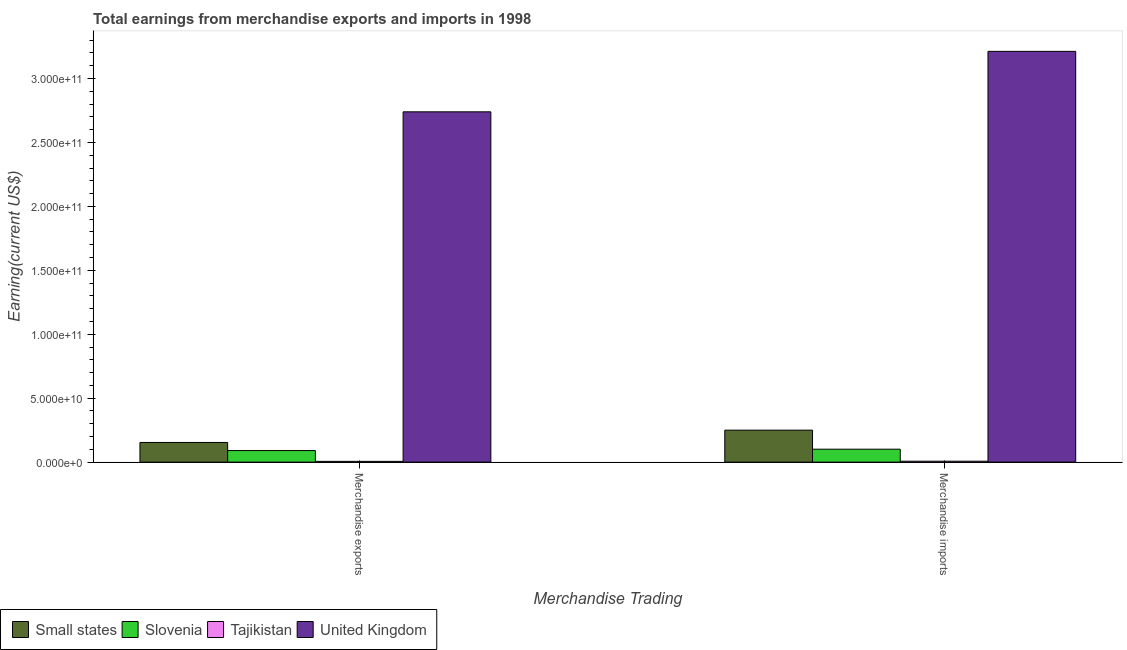How many different coloured bars are there?
Keep it short and to the point. 4. How many groups of bars are there?
Your answer should be very brief. 2. Are the number of bars per tick equal to the number of legend labels?
Keep it short and to the point. Yes. Are the number of bars on each tick of the X-axis equal?
Your answer should be compact. Yes. What is the label of the 2nd group of bars from the left?
Your answer should be compact. Merchandise imports. What is the earnings from merchandise imports in United Kingdom?
Make the answer very short. 3.21e+11. Across all countries, what is the maximum earnings from merchandise exports?
Offer a very short reply. 2.74e+11. Across all countries, what is the minimum earnings from merchandise exports?
Provide a short and direct response. 5.95e+08. In which country was the earnings from merchandise exports maximum?
Keep it short and to the point. United Kingdom. In which country was the earnings from merchandise imports minimum?
Your answer should be very brief. Tajikistan. What is the total earnings from merchandise exports in the graph?
Make the answer very short. 2.99e+11. What is the difference between the earnings from merchandise exports in Slovenia and that in Small states?
Provide a short and direct response. -6.33e+09. What is the difference between the earnings from merchandise exports in Small states and the earnings from merchandise imports in United Kingdom?
Your answer should be compact. -3.06e+11. What is the average earnings from merchandise imports per country?
Make the answer very short. 8.93e+1. What is the difference between the earnings from merchandise imports and earnings from merchandise exports in Slovenia?
Ensure brevity in your answer.  1.06e+09. In how many countries, is the earnings from merchandise imports greater than 220000000000 US$?
Your response must be concise. 1. What is the ratio of the earnings from merchandise imports in Tajikistan to that in United Kingdom?
Your answer should be very brief. 0. What does the 2nd bar from the left in Merchandise exports represents?
Make the answer very short. Slovenia. What does the 4th bar from the right in Merchandise exports represents?
Ensure brevity in your answer.  Small states. How many bars are there?
Your response must be concise. 8. How many countries are there in the graph?
Provide a succinct answer. 4. Are the values on the major ticks of Y-axis written in scientific E-notation?
Keep it short and to the point. Yes. Does the graph contain grids?
Your answer should be very brief. No. How many legend labels are there?
Keep it short and to the point. 4. How are the legend labels stacked?
Provide a succinct answer. Horizontal. What is the title of the graph?
Ensure brevity in your answer.  Total earnings from merchandise exports and imports in 1998. Does "Serbia" appear as one of the legend labels in the graph?
Provide a succinct answer. No. What is the label or title of the X-axis?
Your answer should be compact. Merchandise Trading. What is the label or title of the Y-axis?
Provide a short and direct response. Earning(current US$). What is the Earning(current US$) of Small states in Merchandise exports?
Your answer should be compact. 1.54e+1. What is the Earning(current US$) in Slovenia in Merchandise exports?
Give a very brief answer. 9.05e+09. What is the Earning(current US$) of Tajikistan in Merchandise exports?
Make the answer very short. 5.95e+08. What is the Earning(current US$) of United Kingdom in Merchandise exports?
Give a very brief answer. 2.74e+11. What is the Earning(current US$) in Small states in Merchandise imports?
Offer a terse response. 2.50e+1. What is the Earning(current US$) in Slovenia in Merchandise imports?
Your answer should be compact. 1.01e+1. What is the Earning(current US$) of Tajikistan in Merchandise imports?
Give a very brief answer. 7.10e+08. What is the Earning(current US$) of United Kingdom in Merchandise imports?
Make the answer very short. 3.21e+11. Across all Merchandise Trading, what is the maximum Earning(current US$) of Small states?
Provide a succinct answer. 2.50e+1. Across all Merchandise Trading, what is the maximum Earning(current US$) in Slovenia?
Keep it short and to the point. 1.01e+1. Across all Merchandise Trading, what is the maximum Earning(current US$) in Tajikistan?
Your response must be concise. 7.10e+08. Across all Merchandise Trading, what is the maximum Earning(current US$) in United Kingdom?
Your answer should be compact. 3.21e+11. Across all Merchandise Trading, what is the minimum Earning(current US$) in Small states?
Make the answer very short. 1.54e+1. Across all Merchandise Trading, what is the minimum Earning(current US$) in Slovenia?
Offer a terse response. 9.05e+09. Across all Merchandise Trading, what is the minimum Earning(current US$) in Tajikistan?
Provide a short and direct response. 5.95e+08. Across all Merchandise Trading, what is the minimum Earning(current US$) in United Kingdom?
Your answer should be very brief. 2.74e+11. What is the total Earning(current US$) of Small states in the graph?
Make the answer very short. 4.04e+1. What is the total Earning(current US$) in Slovenia in the graph?
Offer a terse response. 1.92e+1. What is the total Earning(current US$) of Tajikistan in the graph?
Your answer should be very brief. 1.30e+09. What is the total Earning(current US$) in United Kingdom in the graph?
Keep it short and to the point. 5.95e+11. What is the difference between the Earning(current US$) of Small states in Merchandise exports and that in Merchandise imports?
Ensure brevity in your answer.  -9.62e+09. What is the difference between the Earning(current US$) in Slovenia in Merchandise exports and that in Merchandise imports?
Your answer should be very brief. -1.06e+09. What is the difference between the Earning(current US$) of Tajikistan in Merchandise exports and that in Merchandise imports?
Provide a succinct answer. -1.15e+08. What is the difference between the Earning(current US$) in United Kingdom in Merchandise exports and that in Merchandise imports?
Make the answer very short. -4.73e+1. What is the difference between the Earning(current US$) of Small states in Merchandise exports and the Earning(current US$) of Slovenia in Merchandise imports?
Make the answer very short. 5.27e+09. What is the difference between the Earning(current US$) in Small states in Merchandise exports and the Earning(current US$) in Tajikistan in Merchandise imports?
Provide a succinct answer. 1.47e+1. What is the difference between the Earning(current US$) in Small states in Merchandise exports and the Earning(current US$) in United Kingdom in Merchandise imports?
Give a very brief answer. -3.06e+11. What is the difference between the Earning(current US$) in Slovenia in Merchandise exports and the Earning(current US$) in Tajikistan in Merchandise imports?
Your answer should be very brief. 8.34e+09. What is the difference between the Earning(current US$) of Slovenia in Merchandise exports and the Earning(current US$) of United Kingdom in Merchandise imports?
Ensure brevity in your answer.  -3.12e+11. What is the difference between the Earning(current US$) of Tajikistan in Merchandise exports and the Earning(current US$) of United Kingdom in Merchandise imports?
Keep it short and to the point. -3.21e+11. What is the average Earning(current US$) in Small states per Merchandise Trading?
Your answer should be very brief. 2.02e+1. What is the average Earning(current US$) of Slovenia per Merchandise Trading?
Ensure brevity in your answer.  9.58e+09. What is the average Earning(current US$) of Tajikistan per Merchandise Trading?
Your answer should be very brief. 6.52e+08. What is the average Earning(current US$) in United Kingdom per Merchandise Trading?
Your answer should be compact. 2.98e+11. What is the difference between the Earning(current US$) of Small states and Earning(current US$) of Slovenia in Merchandise exports?
Your answer should be compact. 6.33e+09. What is the difference between the Earning(current US$) of Small states and Earning(current US$) of Tajikistan in Merchandise exports?
Provide a short and direct response. 1.48e+1. What is the difference between the Earning(current US$) of Small states and Earning(current US$) of United Kingdom in Merchandise exports?
Provide a succinct answer. -2.59e+11. What is the difference between the Earning(current US$) of Slovenia and Earning(current US$) of Tajikistan in Merchandise exports?
Your response must be concise. 8.45e+09. What is the difference between the Earning(current US$) in Slovenia and Earning(current US$) in United Kingdom in Merchandise exports?
Offer a very short reply. -2.65e+11. What is the difference between the Earning(current US$) in Tajikistan and Earning(current US$) in United Kingdom in Merchandise exports?
Provide a short and direct response. -2.73e+11. What is the difference between the Earning(current US$) of Small states and Earning(current US$) of Slovenia in Merchandise imports?
Provide a short and direct response. 1.49e+1. What is the difference between the Earning(current US$) in Small states and Earning(current US$) in Tajikistan in Merchandise imports?
Give a very brief answer. 2.43e+1. What is the difference between the Earning(current US$) in Small states and Earning(current US$) in United Kingdom in Merchandise imports?
Provide a short and direct response. -2.96e+11. What is the difference between the Earning(current US$) of Slovenia and Earning(current US$) of Tajikistan in Merchandise imports?
Ensure brevity in your answer.  9.40e+09. What is the difference between the Earning(current US$) in Slovenia and Earning(current US$) in United Kingdom in Merchandise imports?
Offer a very short reply. -3.11e+11. What is the difference between the Earning(current US$) of Tajikistan and Earning(current US$) of United Kingdom in Merchandise imports?
Provide a short and direct response. -3.21e+11. What is the ratio of the Earning(current US$) in Small states in Merchandise exports to that in Merchandise imports?
Offer a terse response. 0.62. What is the ratio of the Earning(current US$) in Slovenia in Merchandise exports to that in Merchandise imports?
Your answer should be very brief. 0.9. What is the ratio of the Earning(current US$) in Tajikistan in Merchandise exports to that in Merchandise imports?
Your answer should be very brief. 0.84. What is the ratio of the Earning(current US$) of United Kingdom in Merchandise exports to that in Merchandise imports?
Your answer should be compact. 0.85. What is the difference between the highest and the second highest Earning(current US$) in Small states?
Ensure brevity in your answer.  9.62e+09. What is the difference between the highest and the second highest Earning(current US$) in Slovenia?
Make the answer very short. 1.06e+09. What is the difference between the highest and the second highest Earning(current US$) in Tajikistan?
Make the answer very short. 1.15e+08. What is the difference between the highest and the second highest Earning(current US$) in United Kingdom?
Your answer should be very brief. 4.73e+1. What is the difference between the highest and the lowest Earning(current US$) in Small states?
Your answer should be very brief. 9.62e+09. What is the difference between the highest and the lowest Earning(current US$) of Slovenia?
Make the answer very short. 1.06e+09. What is the difference between the highest and the lowest Earning(current US$) in Tajikistan?
Offer a very short reply. 1.15e+08. What is the difference between the highest and the lowest Earning(current US$) in United Kingdom?
Offer a terse response. 4.73e+1. 